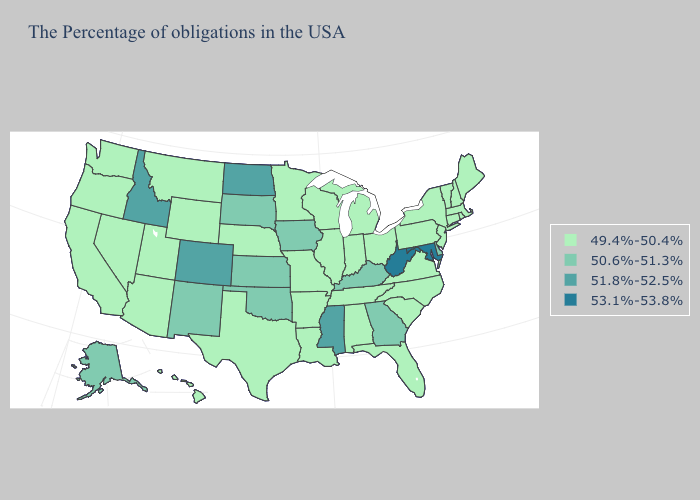Which states have the highest value in the USA?
Short answer required. Maryland, West Virginia. Which states have the highest value in the USA?
Quick response, please. Maryland, West Virginia. Does North Dakota have the lowest value in the USA?
Write a very short answer. No. Name the states that have a value in the range 51.8%-52.5%?
Concise answer only. Mississippi, North Dakota, Colorado, Idaho. What is the lowest value in the USA?
Give a very brief answer. 49.4%-50.4%. Name the states that have a value in the range 50.6%-51.3%?
Answer briefly. Delaware, Georgia, Kentucky, Iowa, Kansas, Oklahoma, South Dakota, New Mexico, Alaska. Does Ohio have a higher value than Louisiana?
Write a very short answer. No. What is the value of South Dakota?
Write a very short answer. 50.6%-51.3%. What is the highest value in states that border West Virginia?
Be succinct. 53.1%-53.8%. What is the value of Tennessee?
Short answer required. 49.4%-50.4%. Does Nebraska have a lower value than South Carolina?
Be succinct. No. Name the states that have a value in the range 49.4%-50.4%?
Short answer required. Maine, Massachusetts, Rhode Island, New Hampshire, Vermont, Connecticut, New York, New Jersey, Pennsylvania, Virginia, North Carolina, South Carolina, Ohio, Florida, Michigan, Indiana, Alabama, Tennessee, Wisconsin, Illinois, Louisiana, Missouri, Arkansas, Minnesota, Nebraska, Texas, Wyoming, Utah, Montana, Arizona, Nevada, California, Washington, Oregon, Hawaii. How many symbols are there in the legend?
Be succinct. 4. What is the value of New York?
Short answer required. 49.4%-50.4%. 